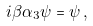Convert formula to latex. <formula><loc_0><loc_0><loc_500><loc_500>i \beta \alpha _ { 3 } \psi = \psi \, ,</formula> 